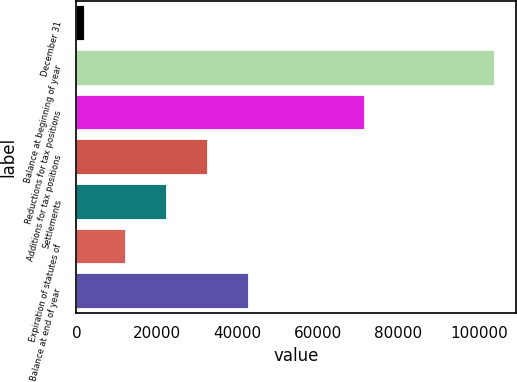<chart> <loc_0><loc_0><loc_500><loc_500><bar_chart><fcel>December 31<fcel>Balance at beginning of year<fcel>Reductions for tax positions<fcel>Additions for tax positions<fcel>Settlements<fcel>Expiration of statutes of<fcel>Balance at end of year<nl><fcel>2014<fcel>103963<fcel>71643<fcel>32598.7<fcel>22403.8<fcel>12208.9<fcel>42793.6<nl></chart> 